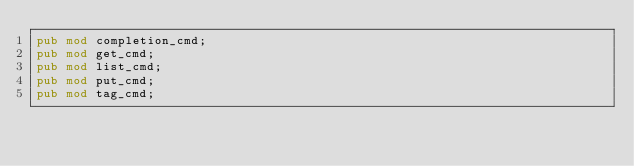<code> <loc_0><loc_0><loc_500><loc_500><_Rust_>pub mod completion_cmd;
pub mod get_cmd;
pub mod list_cmd;
pub mod put_cmd;
pub mod tag_cmd;
</code> 